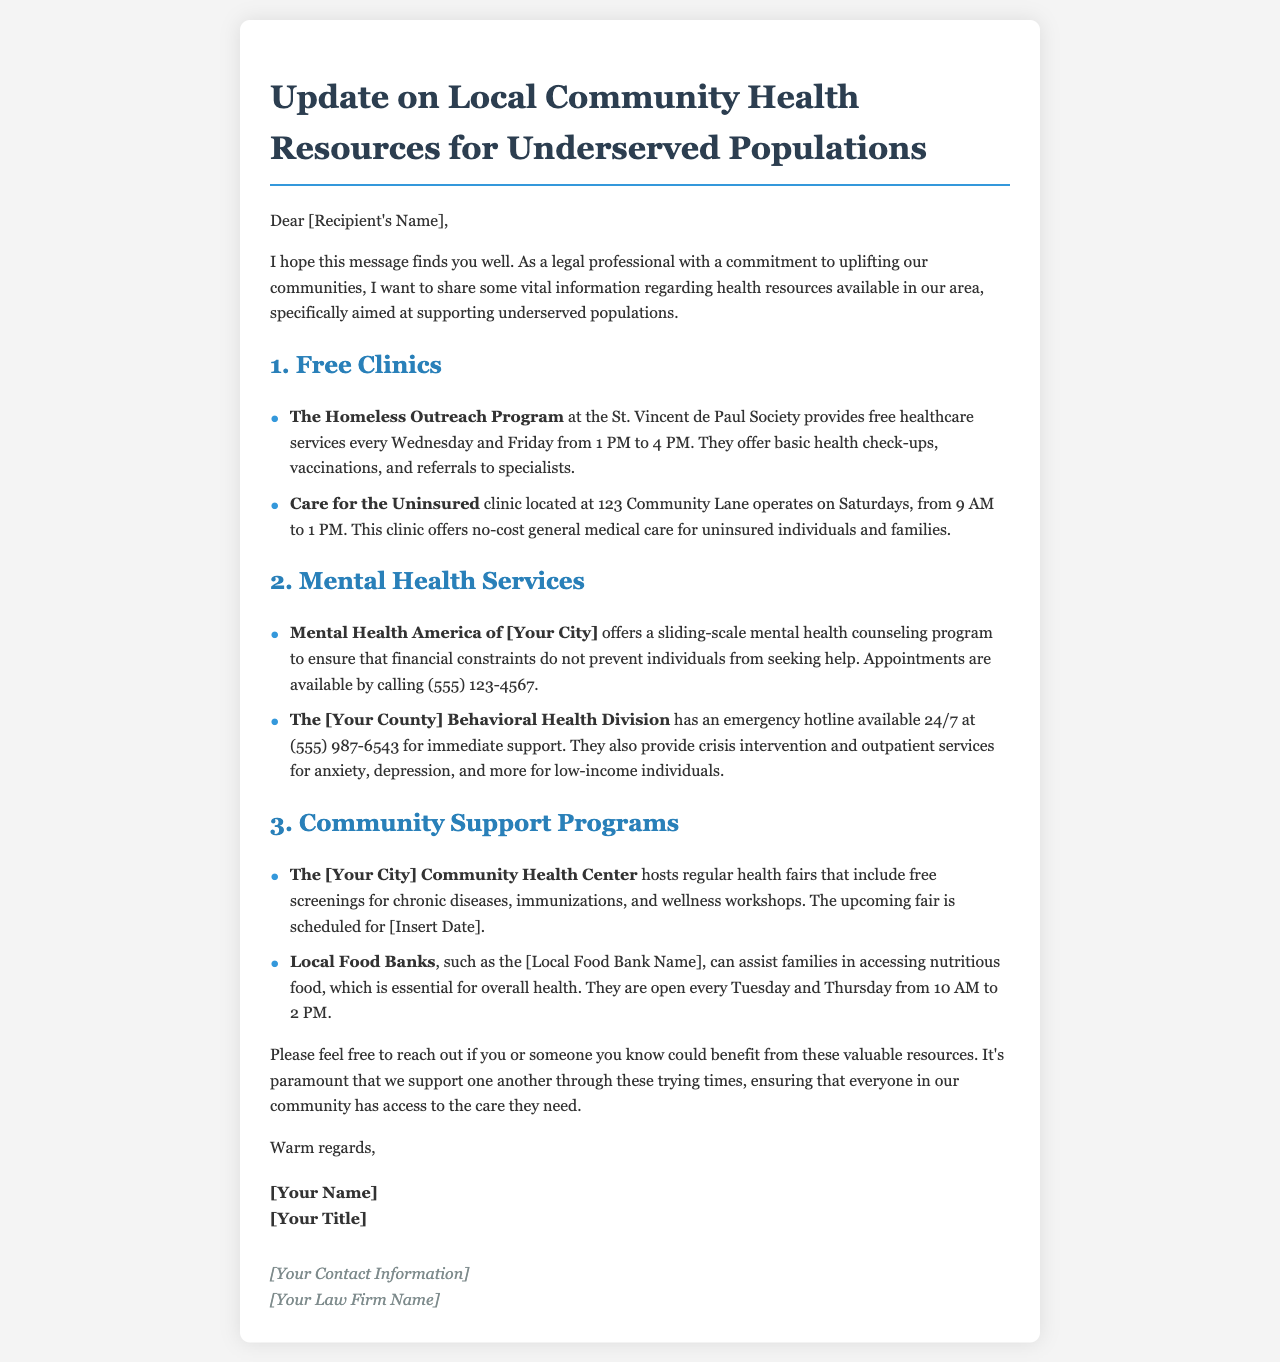What days does The Homeless Outreach Program provide free healthcare services? The document states that this program offers services every Wednesday and Friday.
Answer: Wednesday and Friday What is the address of the Care for the Uninsured clinic? The address for the clinic is provided in the document as 123 Community Lane.
Answer: 123 Community Lane What is the contact number for Mental Health America of [Your City]? The document specifies the contact number as (555) 123-4567.
Answer: (555) 123-4567 What type of program does The [Your County] Behavioral Health Division provide? The document indicates they provide crisis intervention and outpatient services for anxiety, depression, and more.
Answer: crisis intervention and outpatient services What resource is available for immediate mental health support? The document mentions an emergency hotline available 24/7 for immediate support.
Answer: emergency hotline What service does The [Your City] Community Health Center provide during health fairs? The document notes they include free screenings for chronic diseases during health fairs.
Answer: free screenings for chronic diseases How often are local food banks mentioned in the document open? The document states that local food banks are open every Tuesday and Thursday.
Answer: every Tuesday and Thursday What is the purpose of the community support programs mentioned in the document? The document outlines that these programs aim to assist families in accessing nutritious food and health resources.
Answer: assist families in accessing nutritious food and health resources 